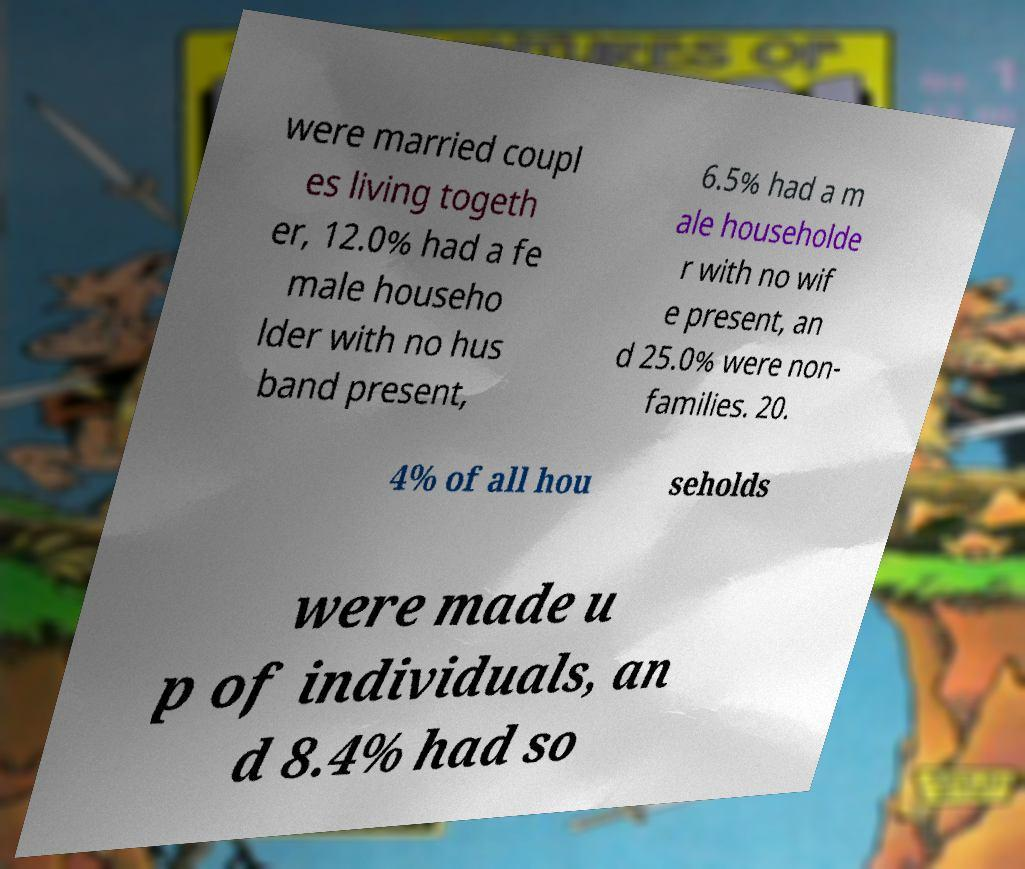There's text embedded in this image that I need extracted. Can you transcribe it verbatim? were married coupl es living togeth er, 12.0% had a fe male househo lder with no hus band present, 6.5% had a m ale householde r with no wif e present, an d 25.0% were non- families. 20. 4% of all hou seholds were made u p of individuals, an d 8.4% had so 